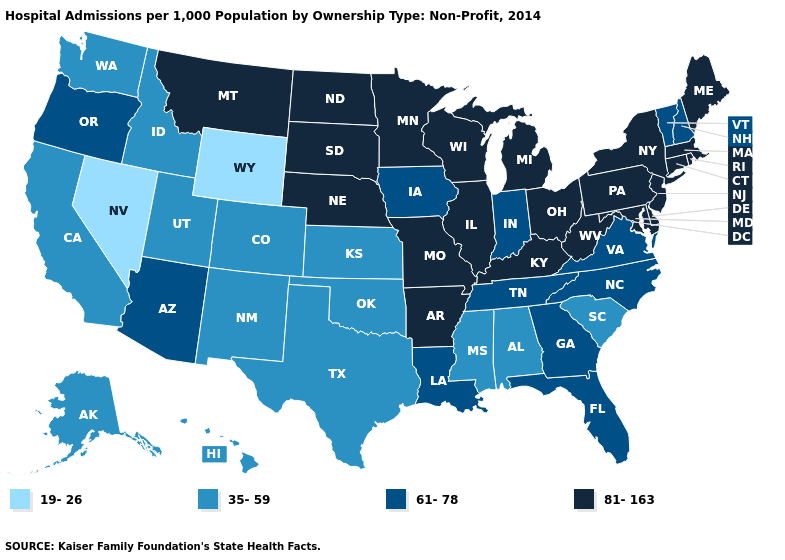What is the value of Mississippi?
Be succinct. 35-59. Name the states that have a value in the range 81-163?
Short answer required. Arkansas, Connecticut, Delaware, Illinois, Kentucky, Maine, Maryland, Massachusetts, Michigan, Minnesota, Missouri, Montana, Nebraska, New Jersey, New York, North Dakota, Ohio, Pennsylvania, Rhode Island, South Dakota, West Virginia, Wisconsin. Name the states that have a value in the range 19-26?
Give a very brief answer. Nevada, Wyoming. Does Wyoming have the lowest value in the USA?
Keep it brief. Yes. Does Florida have a higher value than Indiana?
Answer briefly. No. Among the states that border Mississippi , which have the lowest value?
Quick response, please. Alabama. What is the value of Texas?
Keep it brief. 35-59. Name the states that have a value in the range 35-59?
Keep it brief. Alabama, Alaska, California, Colorado, Hawaii, Idaho, Kansas, Mississippi, New Mexico, Oklahoma, South Carolina, Texas, Utah, Washington. Is the legend a continuous bar?
Give a very brief answer. No. How many symbols are there in the legend?
Write a very short answer. 4. What is the lowest value in the USA?
Answer briefly. 19-26. Does New York have the highest value in the USA?
Quick response, please. Yes. Name the states that have a value in the range 61-78?
Concise answer only. Arizona, Florida, Georgia, Indiana, Iowa, Louisiana, New Hampshire, North Carolina, Oregon, Tennessee, Vermont, Virginia. What is the highest value in states that border New York?
Concise answer only. 81-163. Does Colorado have a lower value than Florida?
Keep it brief. Yes. 